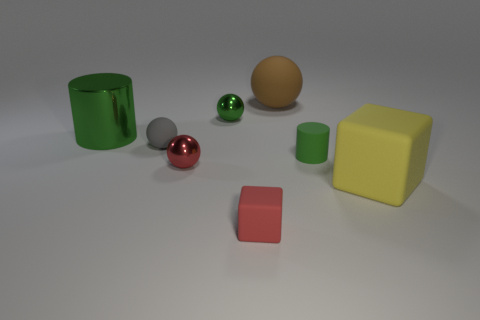Subtract all small red spheres. How many spheres are left? 3 Subtract all yellow blocks. How many blocks are left? 1 Add 1 metal things. How many objects exist? 9 Subtract all cylinders. How many objects are left? 6 Subtract 2 spheres. How many spheres are left? 2 Add 8 yellow matte things. How many yellow matte things are left? 9 Add 7 tiny spheres. How many tiny spheres exist? 10 Subtract 0 blue cylinders. How many objects are left? 8 Subtract all brown balls. Subtract all yellow blocks. How many balls are left? 3 Subtract all small red rubber blocks. Subtract all large rubber cubes. How many objects are left? 6 